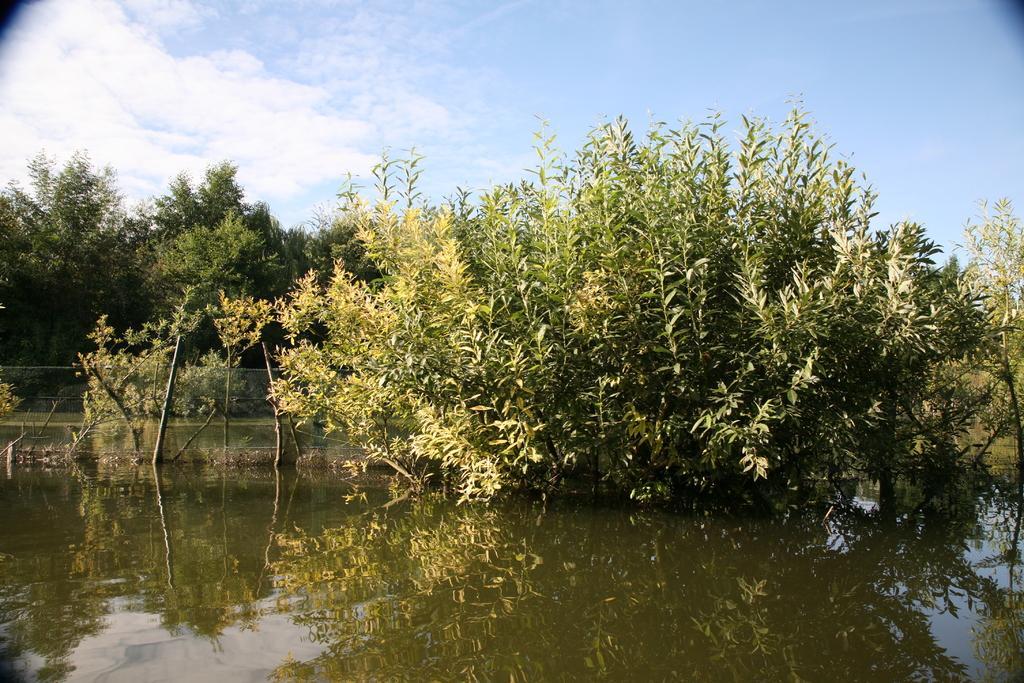Can you describe this image briefly? Front portion of the image we can see water, fence and trees. Background portion of the image there is a cloudy sky. 